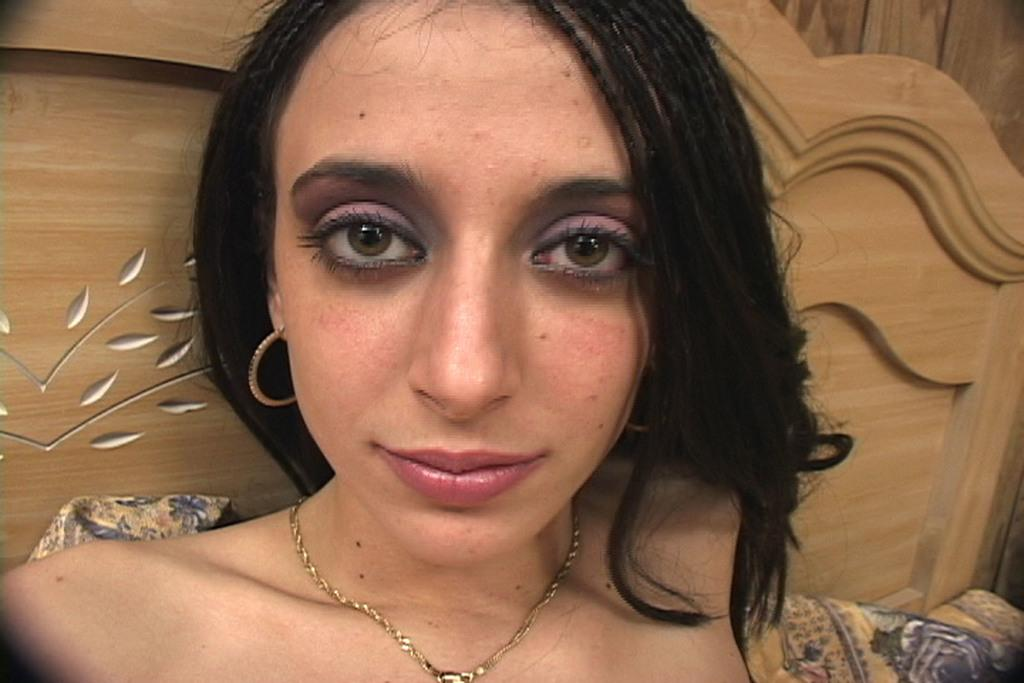Who is present in the image? There is a woman in the image. What is the woman wearing around her neck? The woman is wearing an ornament chain around her neck. What can be seen in the background of the image? There is a wooden block in the background of the image. What type of popcorn is being served in the jail cell in the image? There is no popcorn or jail cell present in the image; it features a woman wearing an ornament chain and a wooden block in the background. 